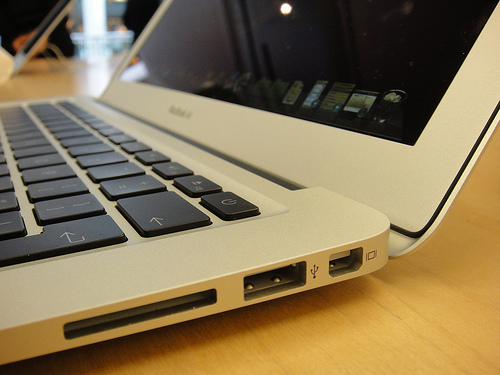<image>
Can you confirm if the laptop is next to the table? No. The laptop is not positioned next to the table. They are located in different areas of the scene. 